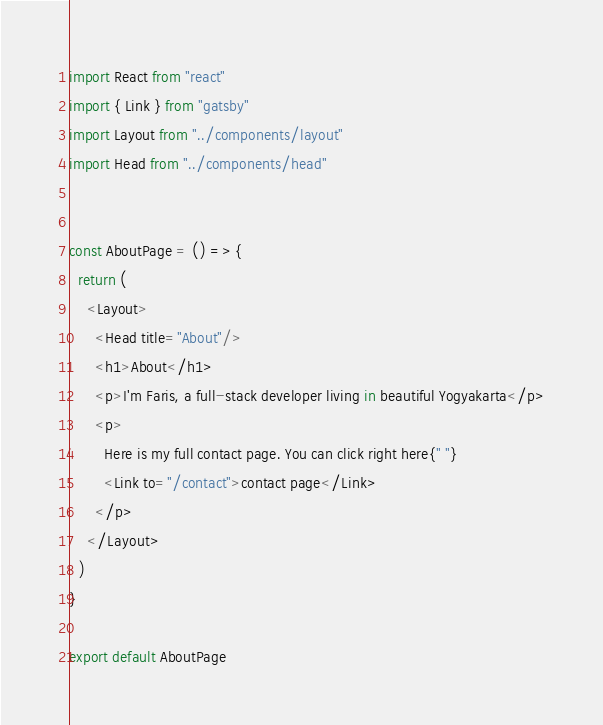<code> <loc_0><loc_0><loc_500><loc_500><_JavaScript_>import React from "react"
import { Link } from "gatsby"
import Layout from "../components/layout"
import Head from "../components/head"


const AboutPage = () => {
  return (
    <Layout>
      <Head title="About"/>
      <h1>About</h1>
      <p>I'm Faris, a full-stack developer living in beautiful Yogyakarta</p>
      <p>
        Here is my full contact page. You can click right here{" "}
        <Link to="/contact">contact page</Link>
      </p>
    </Layout>
  )
}

export default AboutPage
</code> 